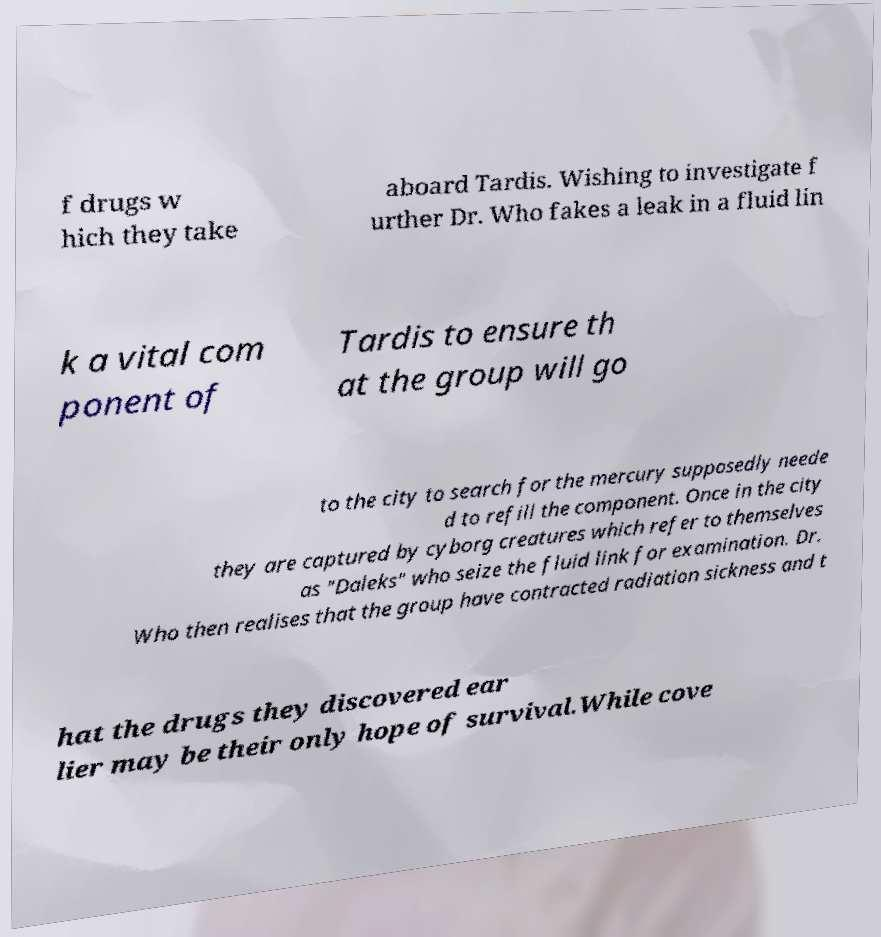For documentation purposes, I need the text within this image transcribed. Could you provide that? f drugs w hich they take aboard Tardis. Wishing to investigate f urther Dr. Who fakes a leak in a fluid lin k a vital com ponent of Tardis to ensure th at the group will go to the city to search for the mercury supposedly neede d to refill the component. Once in the city they are captured by cyborg creatures which refer to themselves as "Daleks" who seize the fluid link for examination. Dr. Who then realises that the group have contracted radiation sickness and t hat the drugs they discovered ear lier may be their only hope of survival.While cove 